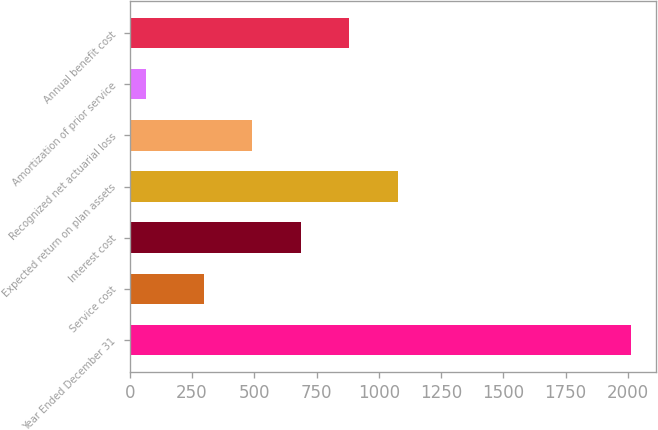Convert chart. <chart><loc_0><loc_0><loc_500><loc_500><bar_chart><fcel>Year Ended December 31<fcel>Service cost<fcel>Interest cost<fcel>Expected return on plan assets<fcel>Recognized net actuarial loss<fcel>Amortization of prior service<fcel>Annual benefit cost<nl><fcel>2013<fcel>298<fcel>687.2<fcel>1076.4<fcel>492.6<fcel>67<fcel>881.8<nl></chart> 